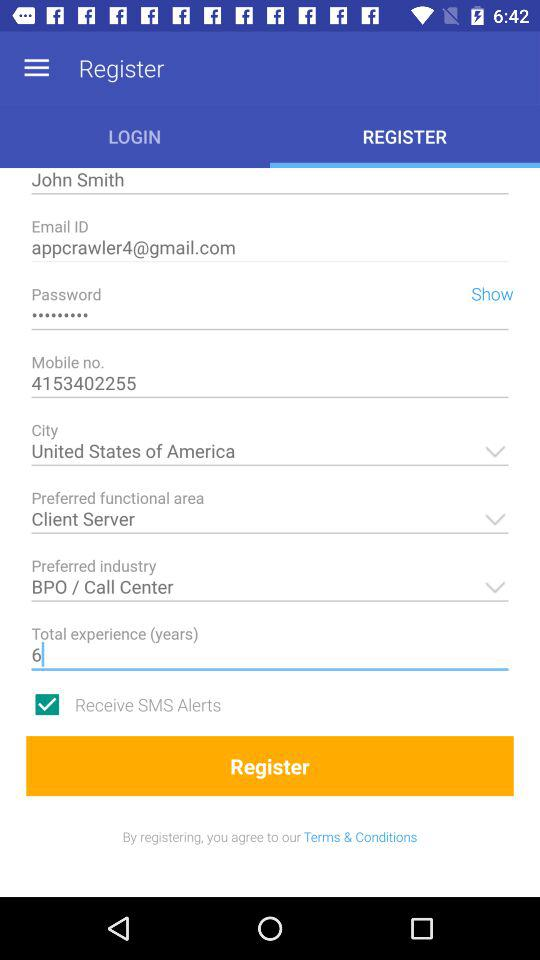What is the email address? The email address is appcrawler4@gmail.com. 